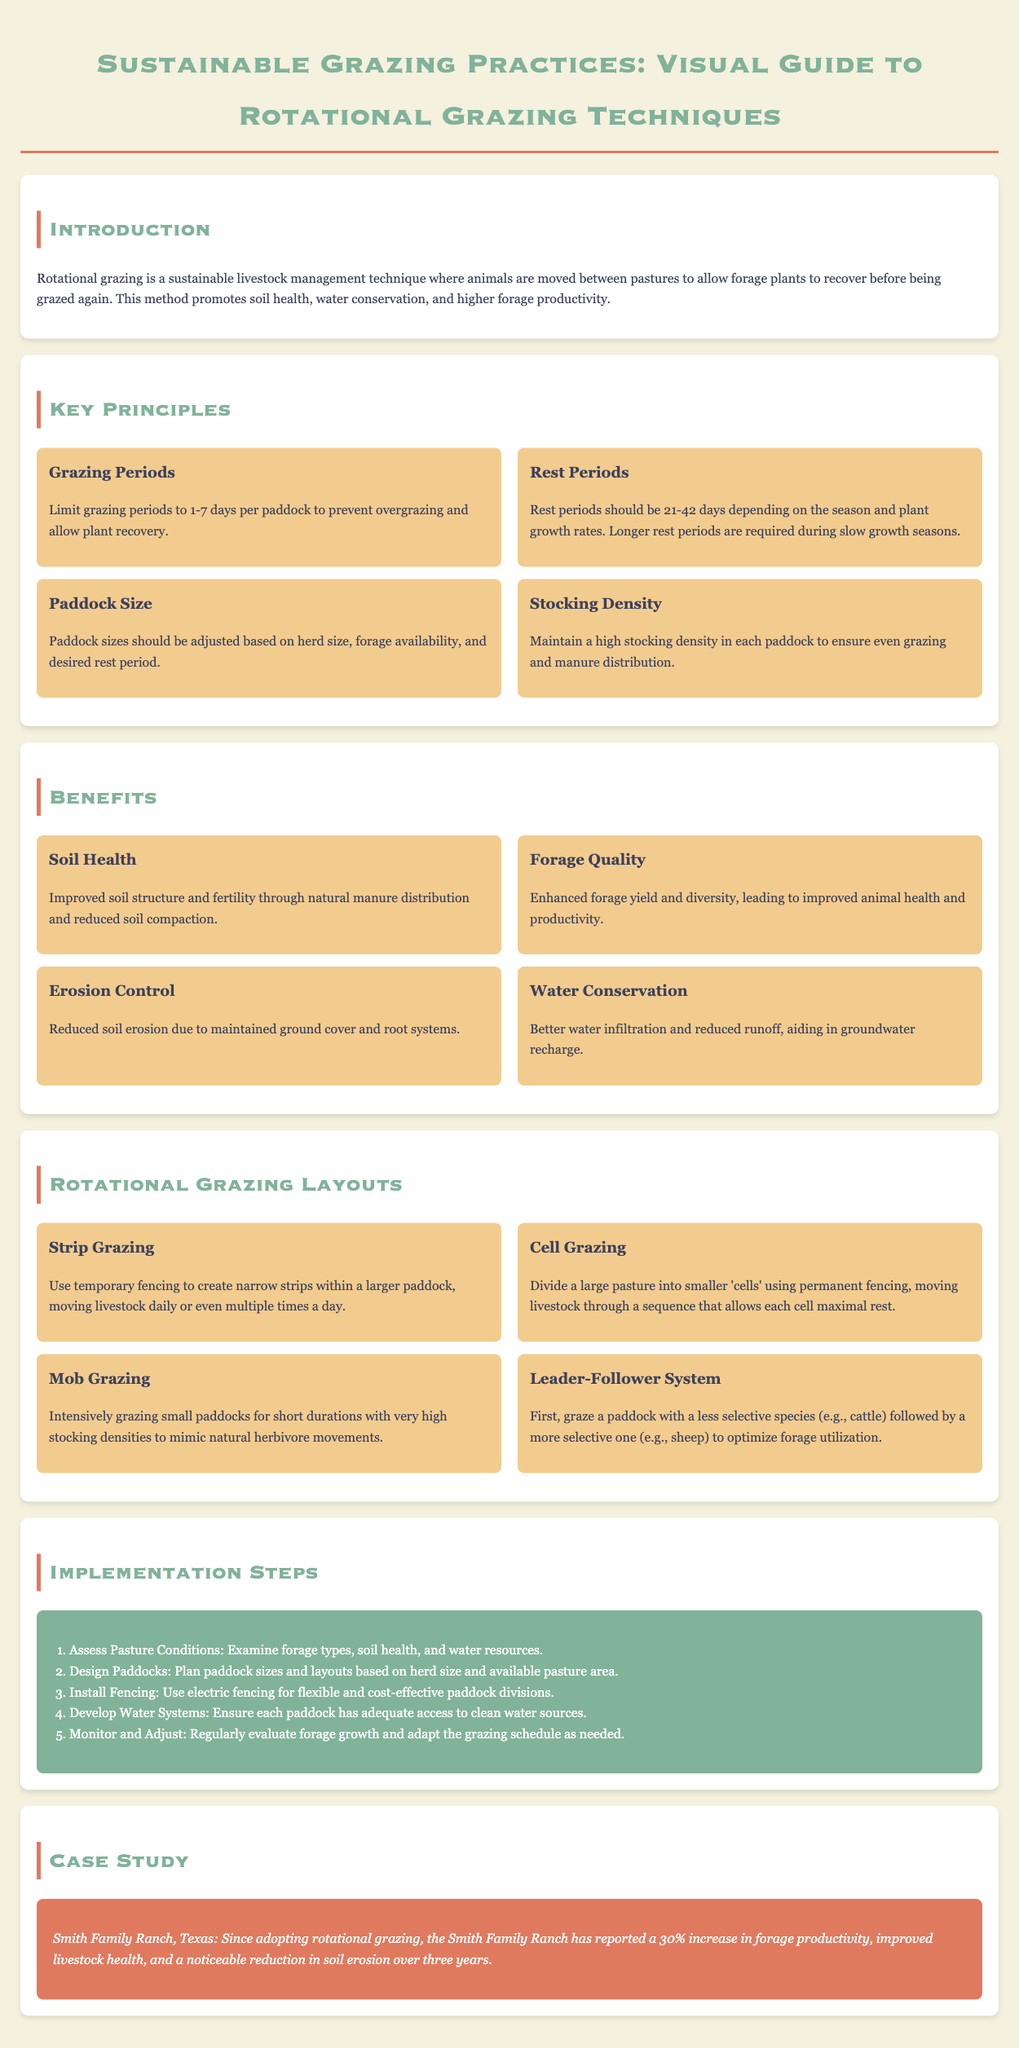What is rotational grazing? Rotational grazing is a sustainable livestock management technique where animals are moved between pastures to allow forage plants to recover.
Answer: sustainable livestock management technique What are the recommended grazing periods? Grazing periods should be limited to prevent overgrazing, which is advised to be between 1-7 days per paddock.
Answer: 1-7 days How long should the rest periods be? Rest periods depend on the season and plant growth rates, with a recommendation of 21-42 days.
Answer: 21-42 days What is one benefit of rotational grazing related to soil? One benefit of rotational grazing is improved soil structure and fertility.
Answer: improved soil structure and fertility What grazing technique uses temporary fencing and allows movement daily? The technique described is Strip Grazing, which involves creating narrow strips for livestock.
Answer: Strip Grazing How much increase in forage productivity was reported by Smith Family Ranch? The report states a 30% increase in forage productivity after adopting rotational grazing.
Answer: 30% What should be assessed when starting rotational grazing? Pasture conditions including forage types, soil health, and water resources should be assessed.
Answer: Pasture conditions What is a key installation needed for rotational grazing? Electric fencing is recommended for flexible and cost-effective paddock divisions.
Answer: Electric fencing What should be monitored and adjusted in rotational grazing systems? Forage growth should be regularly evaluated and adapted in the grazing schedule as needed.
Answer: Forage growth 